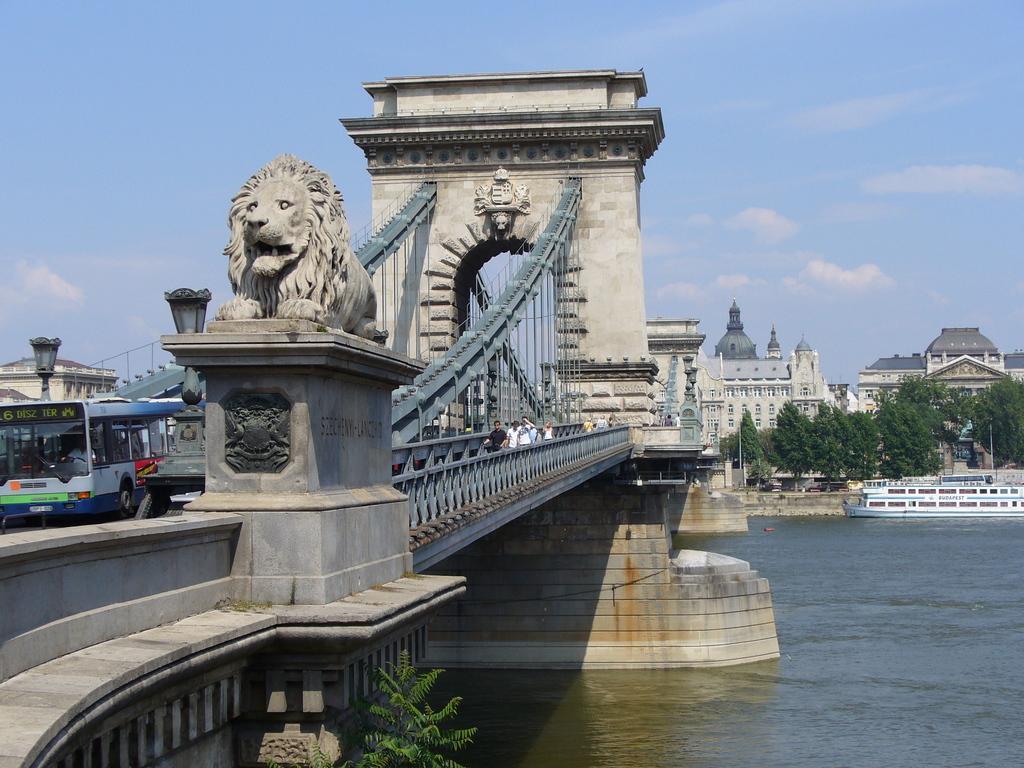Please provide a concise description of this image. This looks like a river with the water. I think this is a bridge, which is across the river. I can see a bus and few people standing on the bridge. This is a sculpture of a lion. These are the buildings and the trees. This looks like a boat, which is on the water. I think these are the lamps. This is the sky. 